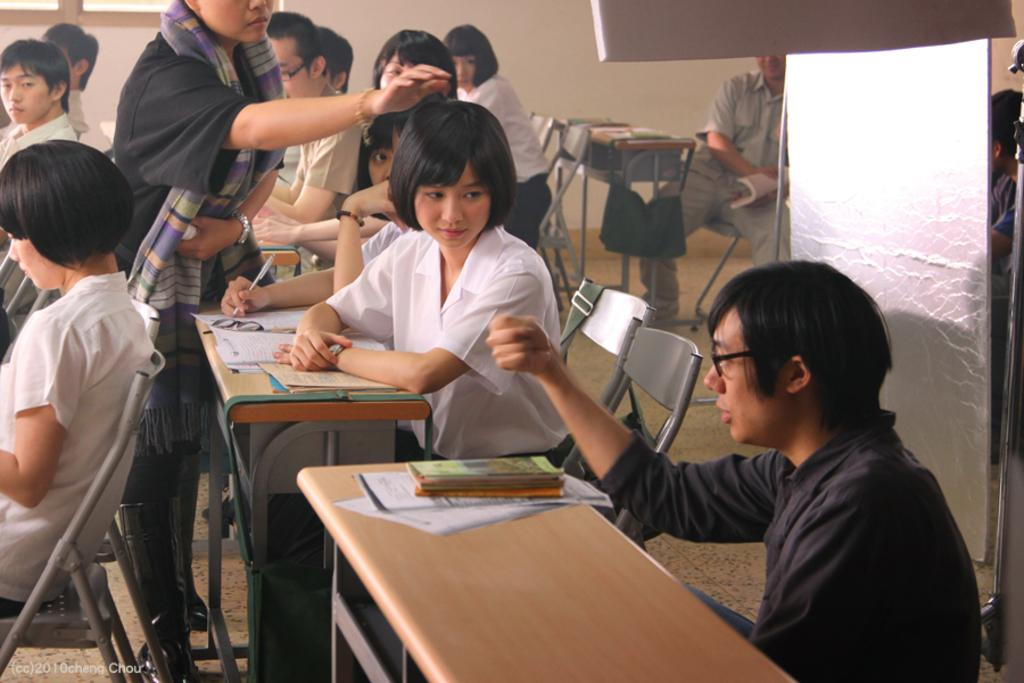What are the people in the image doing? The people in the image are sitting on chairs. Can you describe the woman in the image? There is a woman standing in the image. What type of kite is the woman holding in the image? There is no kite present in the image; the woman is standing without holding any object. How many pears are visible on the chairs in the image? There are no pears visible in the image; the chairs are occupied by people. 